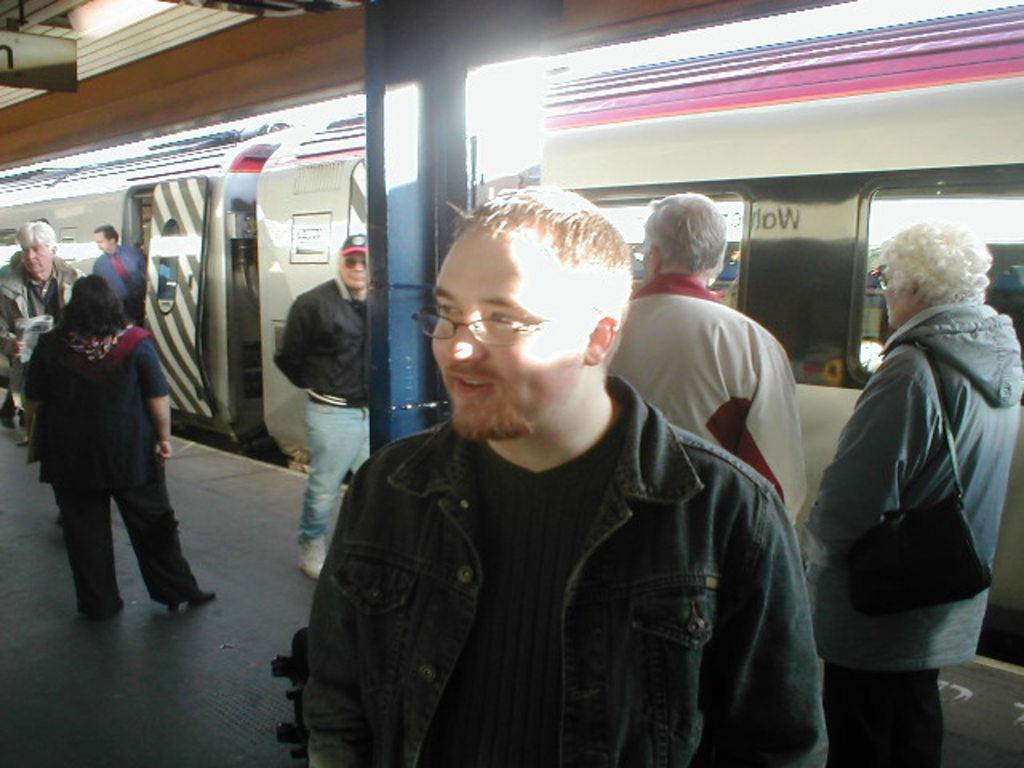What can be seen in the image involving people? There are people standing in the image. What is the location of the people in the image? The location appears to be a platform. What mode of transportation is present in the image? A train is present in the image. What architectural feature can be seen in the image? There is an iron pillar in the image. What sign or notice is visible in the image? There is a board in the image. What type of toad can be seen hopping on the train in the image? There is no toad present in the image, and no toads are hopping on the train. 